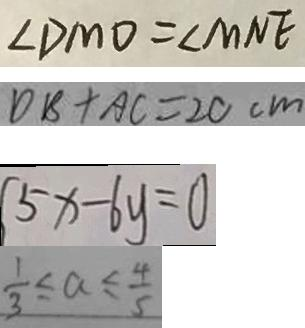<formula> <loc_0><loc_0><loc_500><loc_500>\angle D M O = \angle M N E 
 D B + A C = 2 C c m 
 5 x - 6 y = 0 
 \frac { 1 } { 3 } \leq a \leq \frac { 4 } { 5 }</formula> 